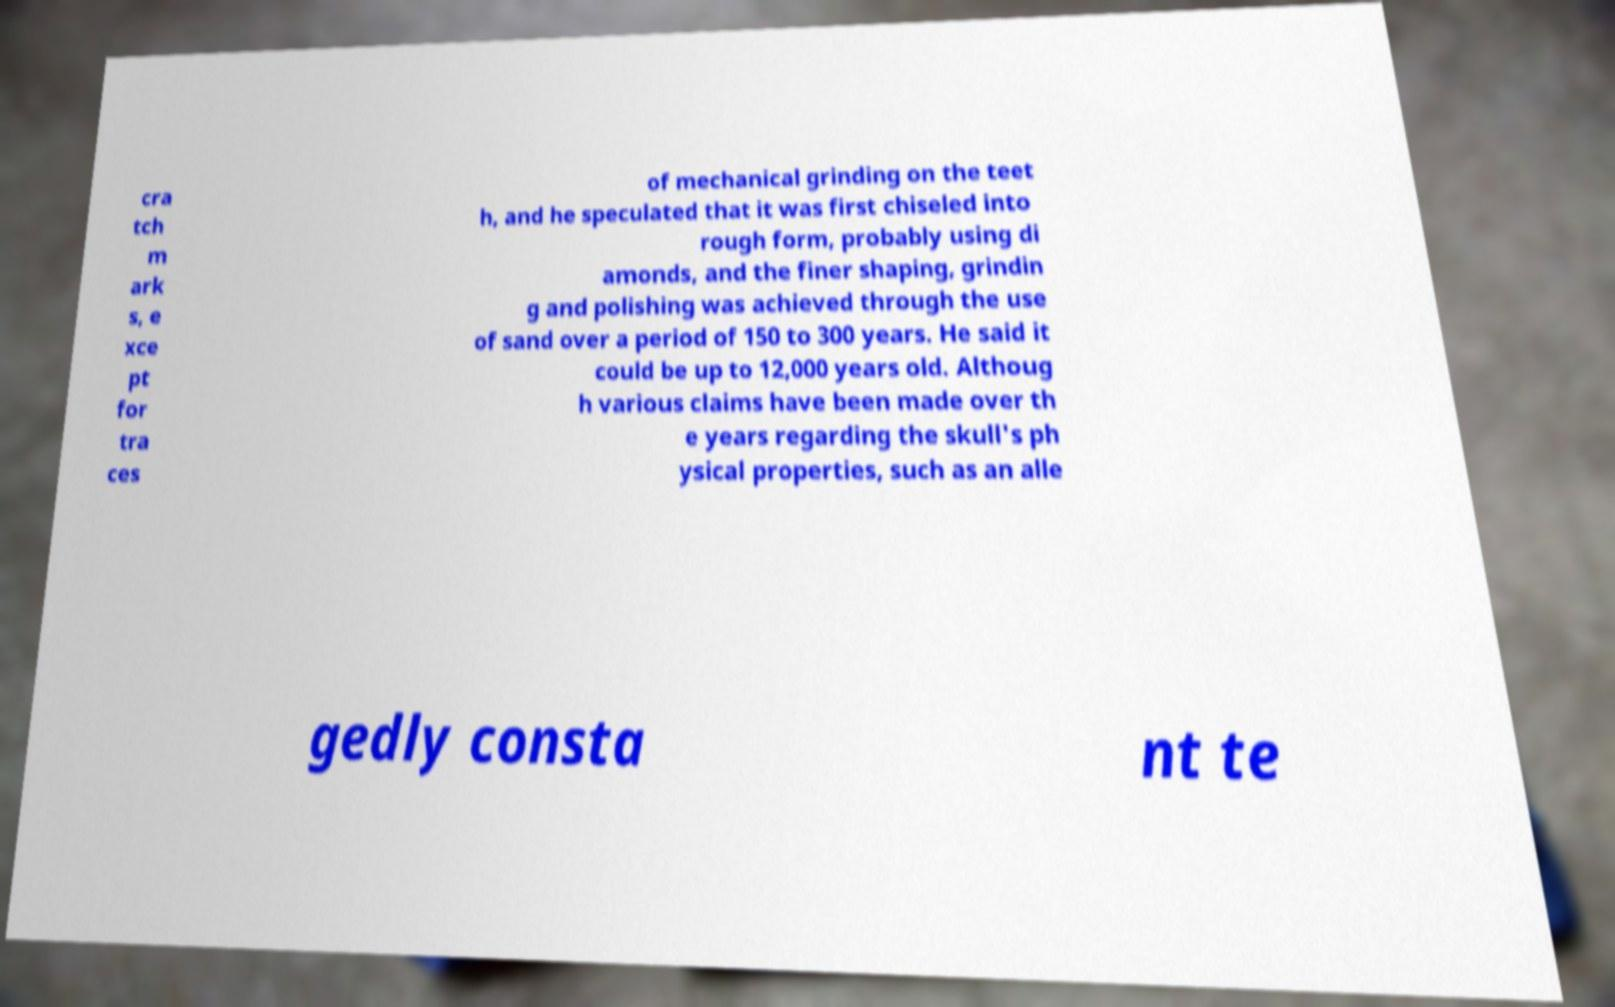There's text embedded in this image that I need extracted. Can you transcribe it verbatim? cra tch m ark s, e xce pt for tra ces of mechanical grinding on the teet h, and he speculated that it was first chiseled into rough form, probably using di amonds, and the finer shaping, grindin g and polishing was achieved through the use of sand over a period of 150 to 300 years. He said it could be up to 12,000 years old. Althoug h various claims have been made over th e years regarding the skull's ph ysical properties, such as an alle gedly consta nt te 